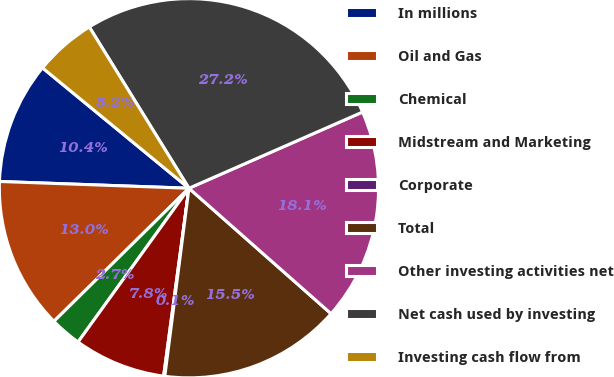<chart> <loc_0><loc_0><loc_500><loc_500><pie_chart><fcel>In millions<fcel>Oil and Gas<fcel>Chemical<fcel>Midstream and Marketing<fcel>Corporate<fcel>Total<fcel>Other investing activities net<fcel>Net cash used by investing<fcel>Investing cash flow from<nl><fcel>10.38%<fcel>12.95%<fcel>2.67%<fcel>7.81%<fcel>0.1%<fcel>15.52%<fcel>18.09%<fcel>27.22%<fcel>5.24%<nl></chart> 